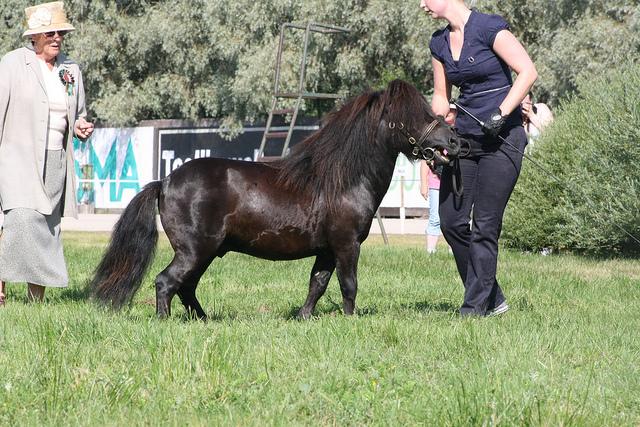What is the woman wearing on her face?
Concise answer only. Sunglasses. What type of horse is this?
Write a very short answer. Pony. Is this horse in a zoo?
Be succinct. No. Is the woman wearing a skirt?
Keep it brief. Yes. What color is the horse?
Concise answer only. Brown. 